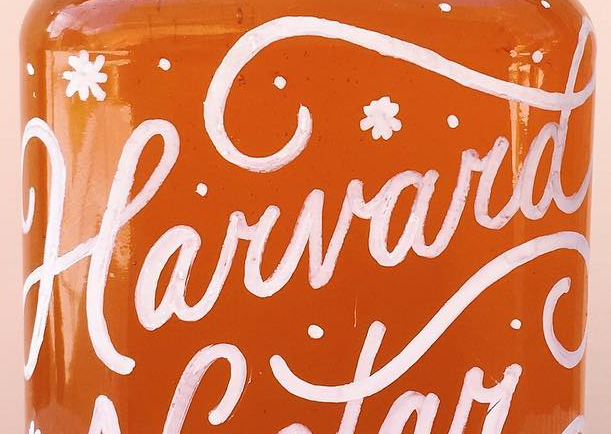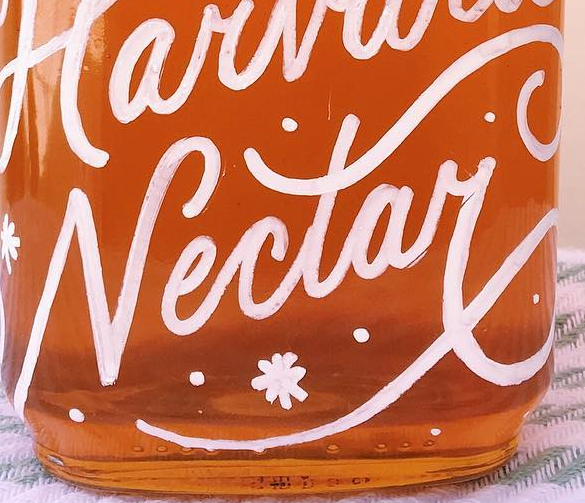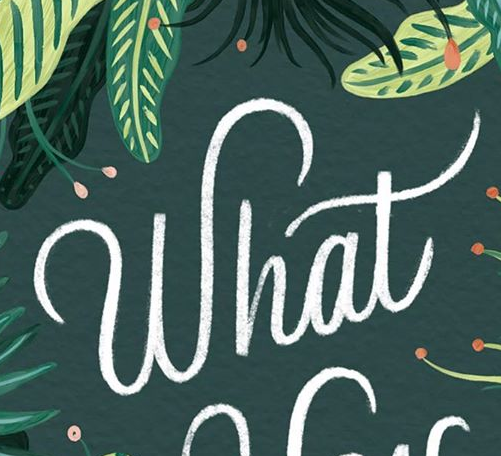What text is displayed in these images sequentially, separated by a semicolon? Harvard; Nectay; What 